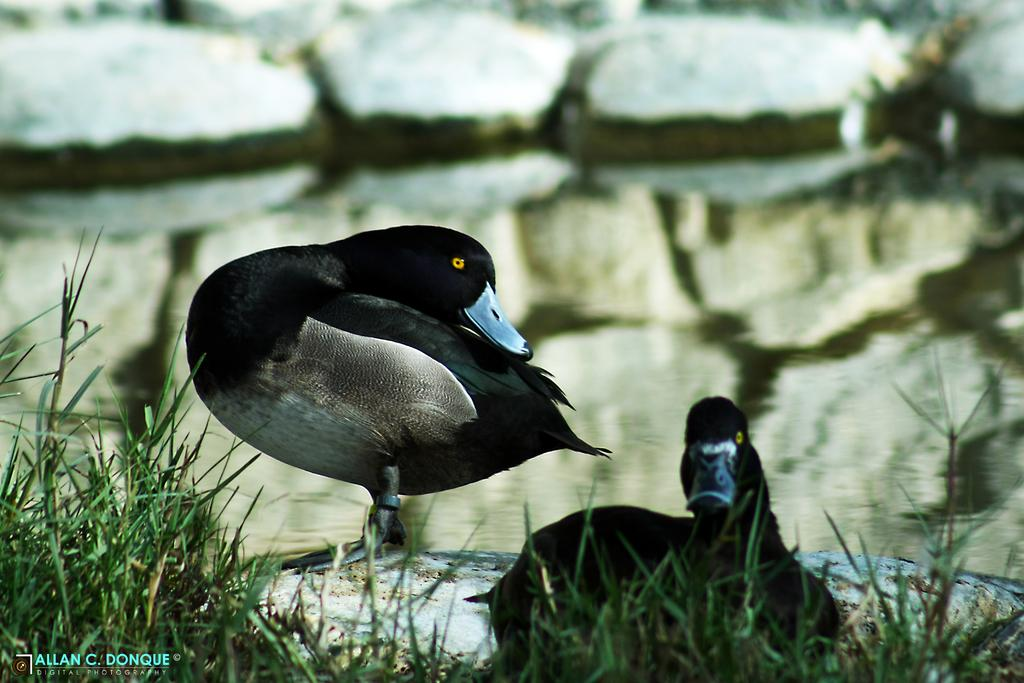How many birds are in the image? There are two birds in the image. What colors can be seen on the birds? The birds have black, white, and brown colors. What type of vegetation is present in the image? There is green grass in the image. What other natural element can be seen? There is a rock in the image. What is the water source in the image? There is water visible in the image. What type of skate is being used by the bear in the image? There is no bear or skate present in the image. What answer is the bird providing in the image? The birds in the image are not providing any answers, as they are not engaged in a conversation or activity that involves answering questions. 